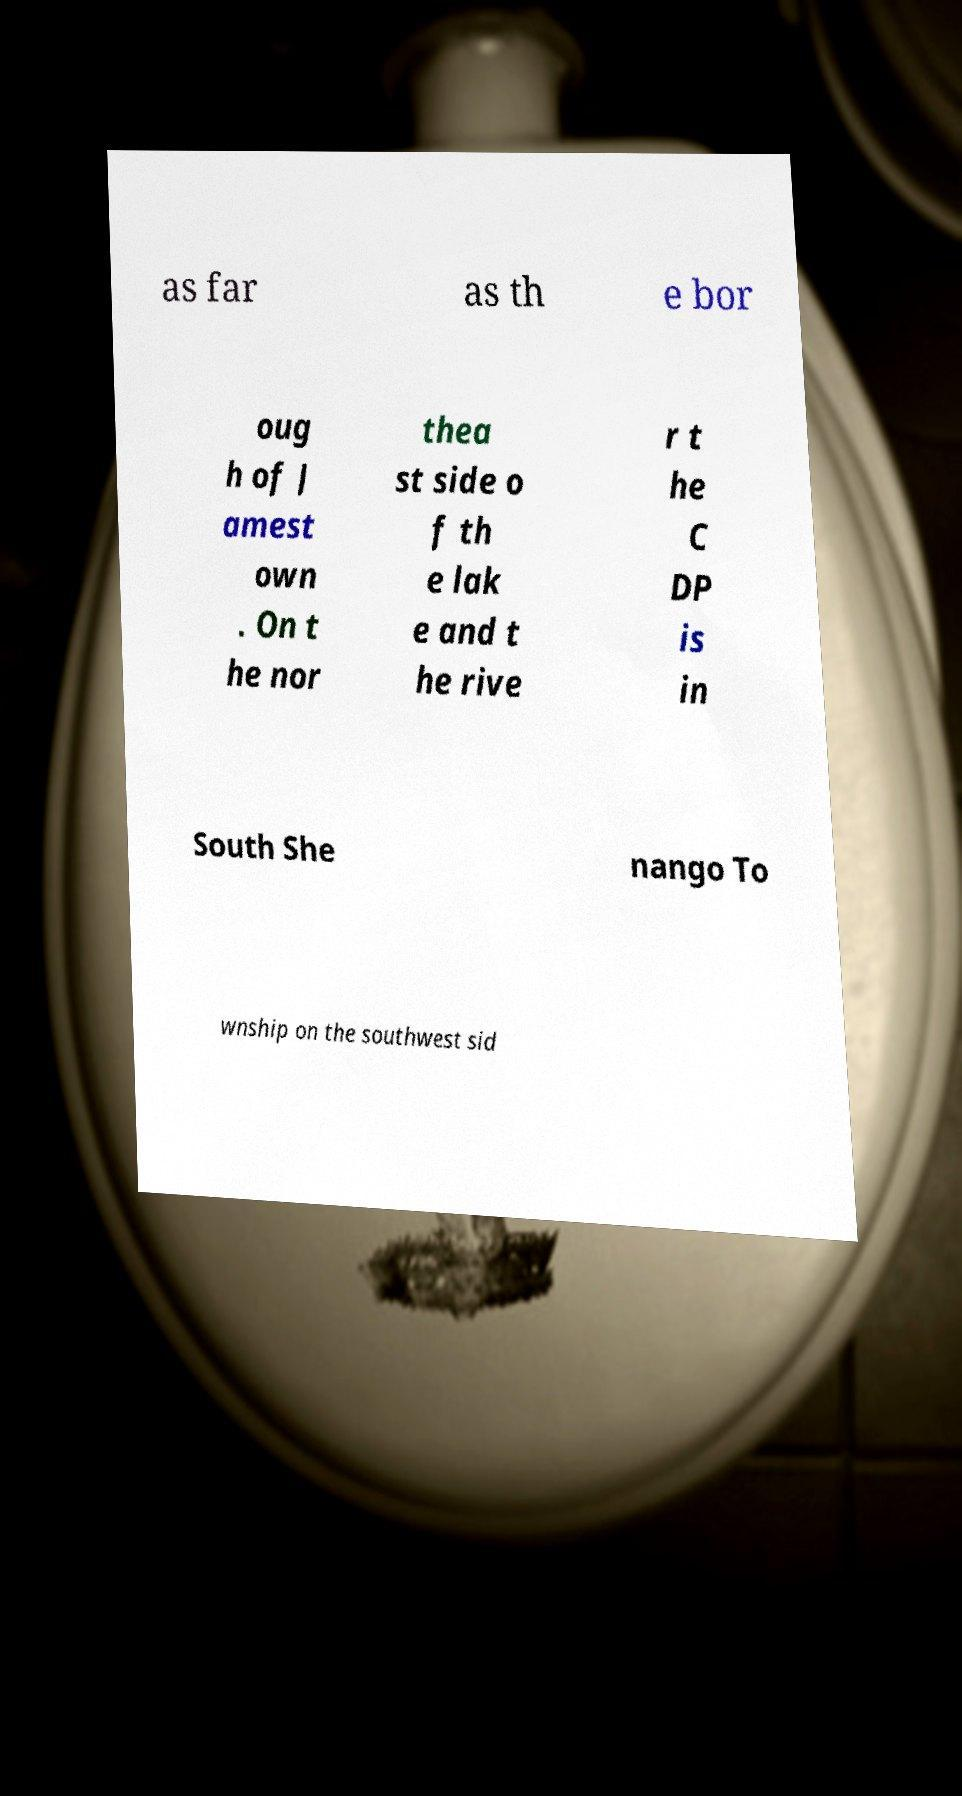There's text embedded in this image that I need extracted. Can you transcribe it verbatim? as far as th e bor oug h of J amest own . On t he nor thea st side o f th e lak e and t he rive r t he C DP is in South She nango To wnship on the southwest sid 